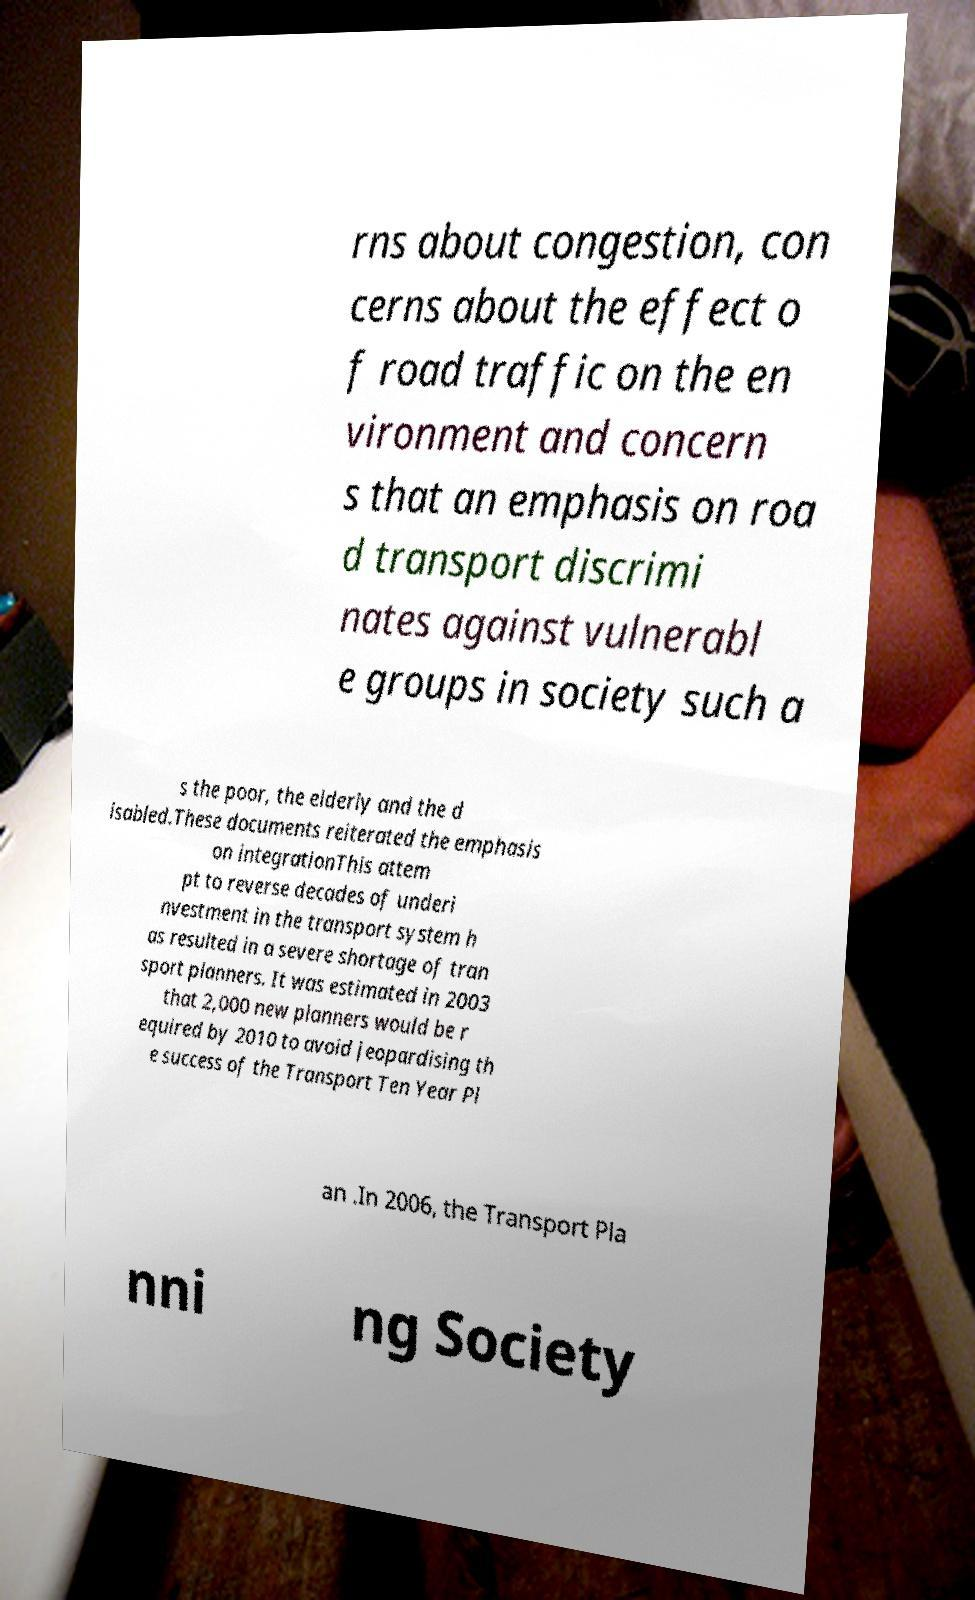For documentation purposes, I need the text within this image transcribed. Could you provide that? rns about congestion, con cerns about the effect o f road traffic on the en vironment and concern s that an emphasis on roa d transport discrimi nates against vulnerabl e groups in society such a s the poor, the elderly and the d isabled.These documents reiterated the emphasis on integrationThis attem pt to reverse decades of underi nvestment in the transport system h as resulted in a severe shortage of tran sport planners. It was estimated in 2003 that 2,000 new planners would be r equired by 2010 to avoid jeopardising th e success of the Transport Ten Year Pl an .In 2006, the Transport Pla nni ng Society 